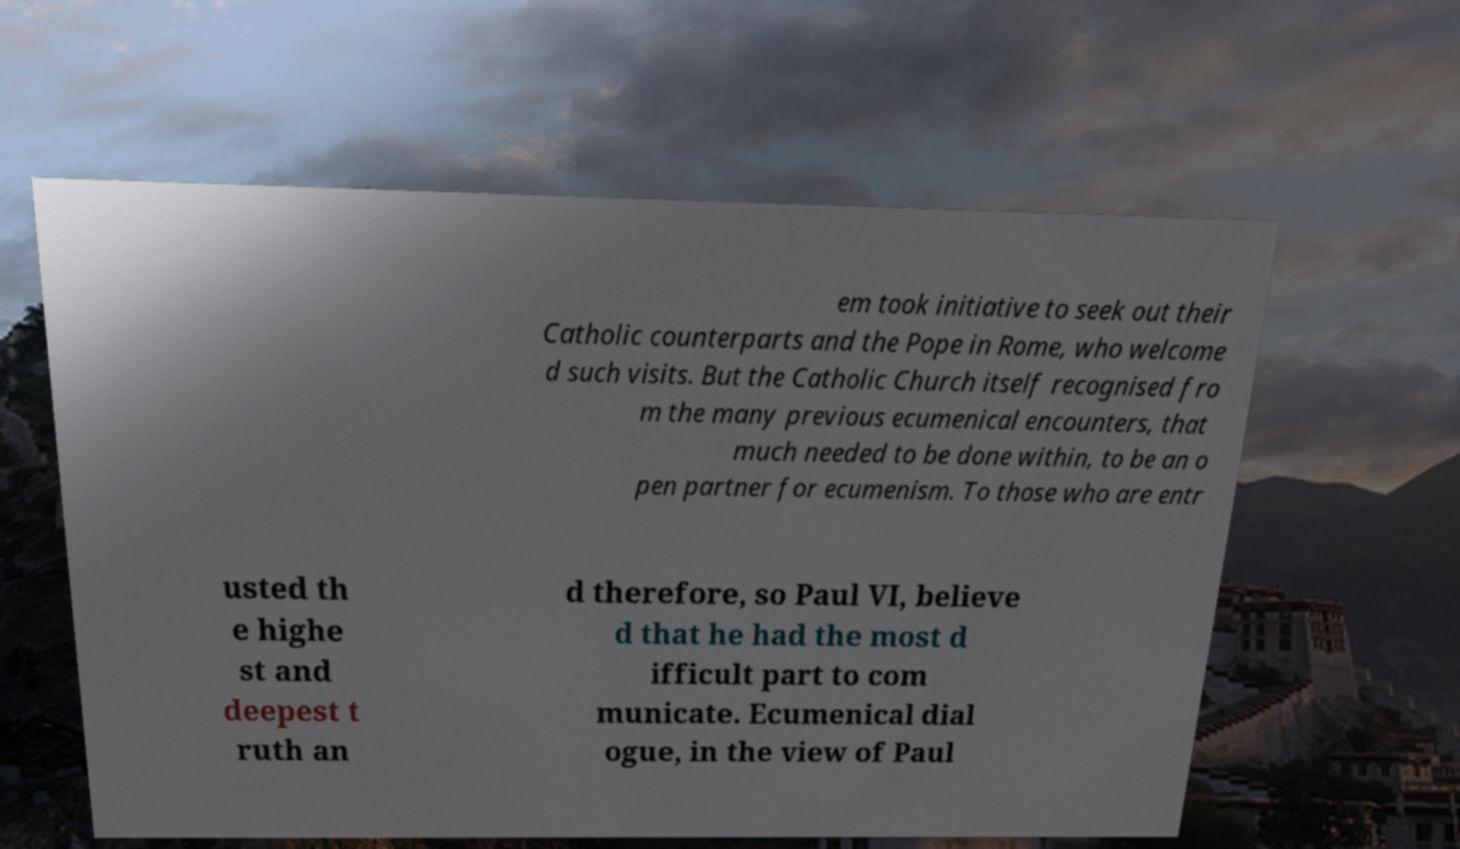What messages or text are displayed in this image? I need them in a readable, typed format. em took initiative to seek out their Catholic counterparts and the Pope in Rome, who welcome d such visits. But the Catholic Church itself recognised fro m the many previous ecumenical encounters, that much needed to be done within, to be an o pen partner for ecumenism. To those who are entr usted th e highe st and deepest t ruth an d therefore, so Paul VI, believe d that he had the most d ifficult part to com municate. Ecumenical dial ogue, in the view of Paul 